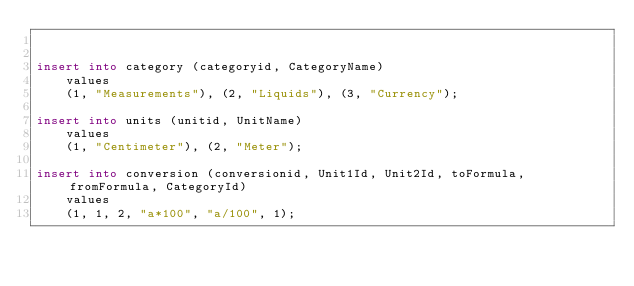<code> <loc_0><loc_0><loc_500><loc_500><_SQL_>

insert into category (categoryid, CategoryName)
    values
    (1, "Measurements"), (2, "Liquids"), (3, "Currency");

insert into units (unitid, UnitName)
    values
    (1, "Centimeter"), (2, "Meter");

insert into conversion (conversionid, Unit1Id, Unit2Id, toFormula, fromFormula, CategoryId)
    values
    (1, 1, 2, "a*100", "a/100", 1);
</code> 